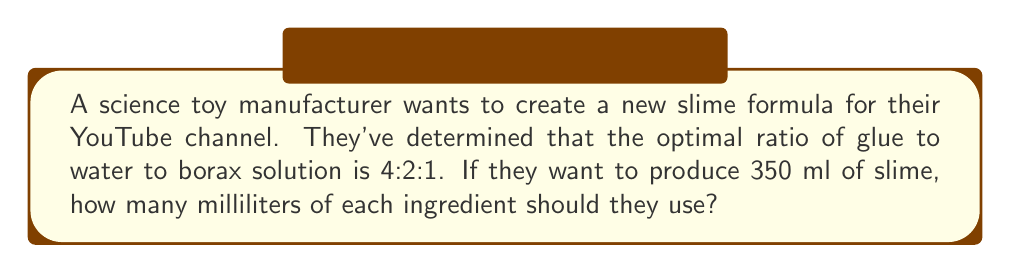Teach me how to tackle this problem. Let's approach this step-by-step:

1) First, we need to understand what the ratio 4:2:1 means:
   - For every 4 parts of glue
   - There are 2 parts of water
   - And 1 part of borax solution

2) Let's add up the total parts:
   $4 + 2 + 1 = 7$ parts in total

3) Now, we need to find out how much one "part" is:
   If 7 parts make 350 ml, then:
   $$\text{1 part} = \frac{350 \text{ ml}}{7} = 50 \text{ ml}$$

4) Now we can calculate the amount of each ingredient:
   - Glue: $4 \times 50 \text{ ml} = 200 \text{ ml}$
   - Water: $2 \times 50 \text{ ml} = 100 \text{ ml}$
   - Borax solution: $1 \times 50 \text{ ml} = 50 \text{ ml}$

5) Let's verify:
   $200 \text{ ml} + 100 \text{ ml} + 50 \text{ ml} = 350 \text{ ml}$

Thus, we've correctly divided the 350 ml into the right proportions.
Answer: 200 ml glue, 100 ml water, 50 ml borax solution 